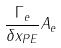Convert formula to latex. <formula><loc_0><loc_0><loc_500><loc_500>\frac { \Gamma _ { e } } { \delta x _ { P E } } A _ { e }</formula> 